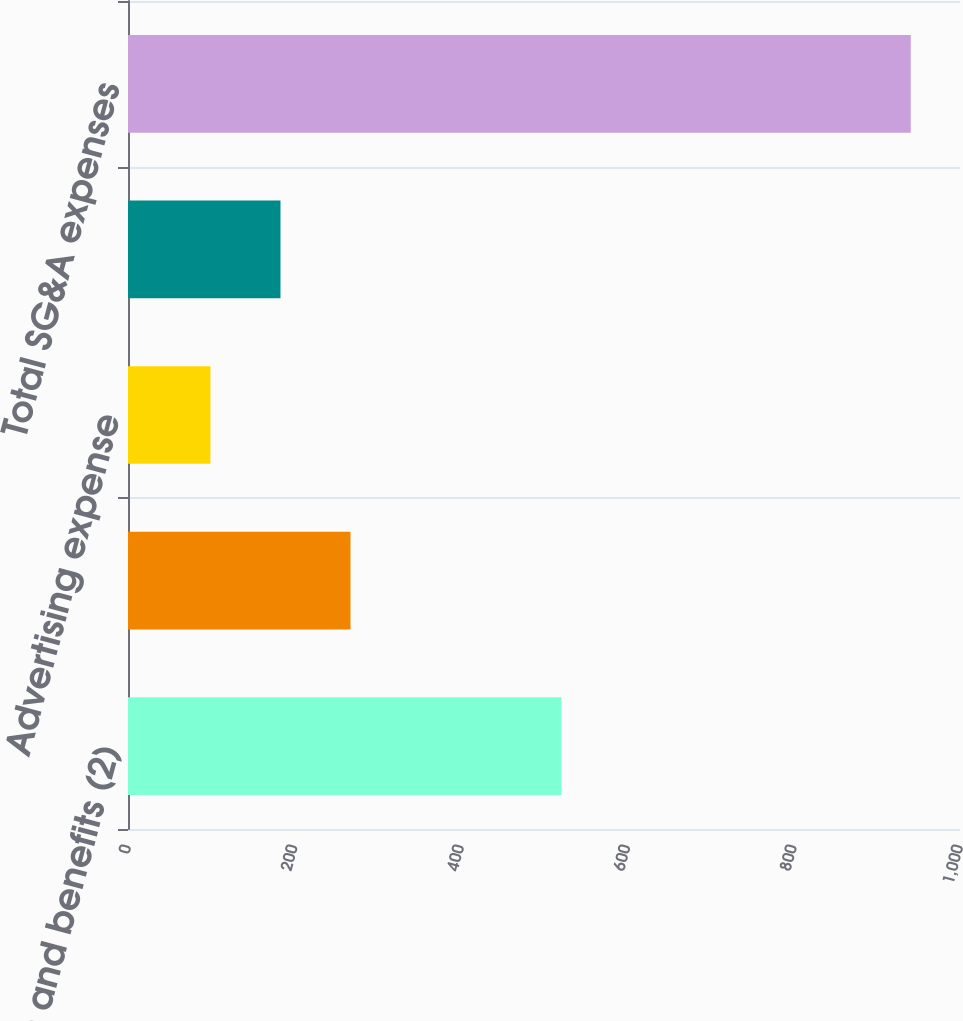Convert chart. <chart><loc_0><loc_0><loc_500><loc_500><bar_chart><fcel>Compensation and benefits (2)<fcel>Store occupancy costs<fcel>Advertising expense<fcel>Other overhead costs (3)<fcel>Total SG&A expenses<nl><fcel>521<fcel>267.44<fcel>99.1<fcel>183.27<fcel>940.8<nl></chart> 